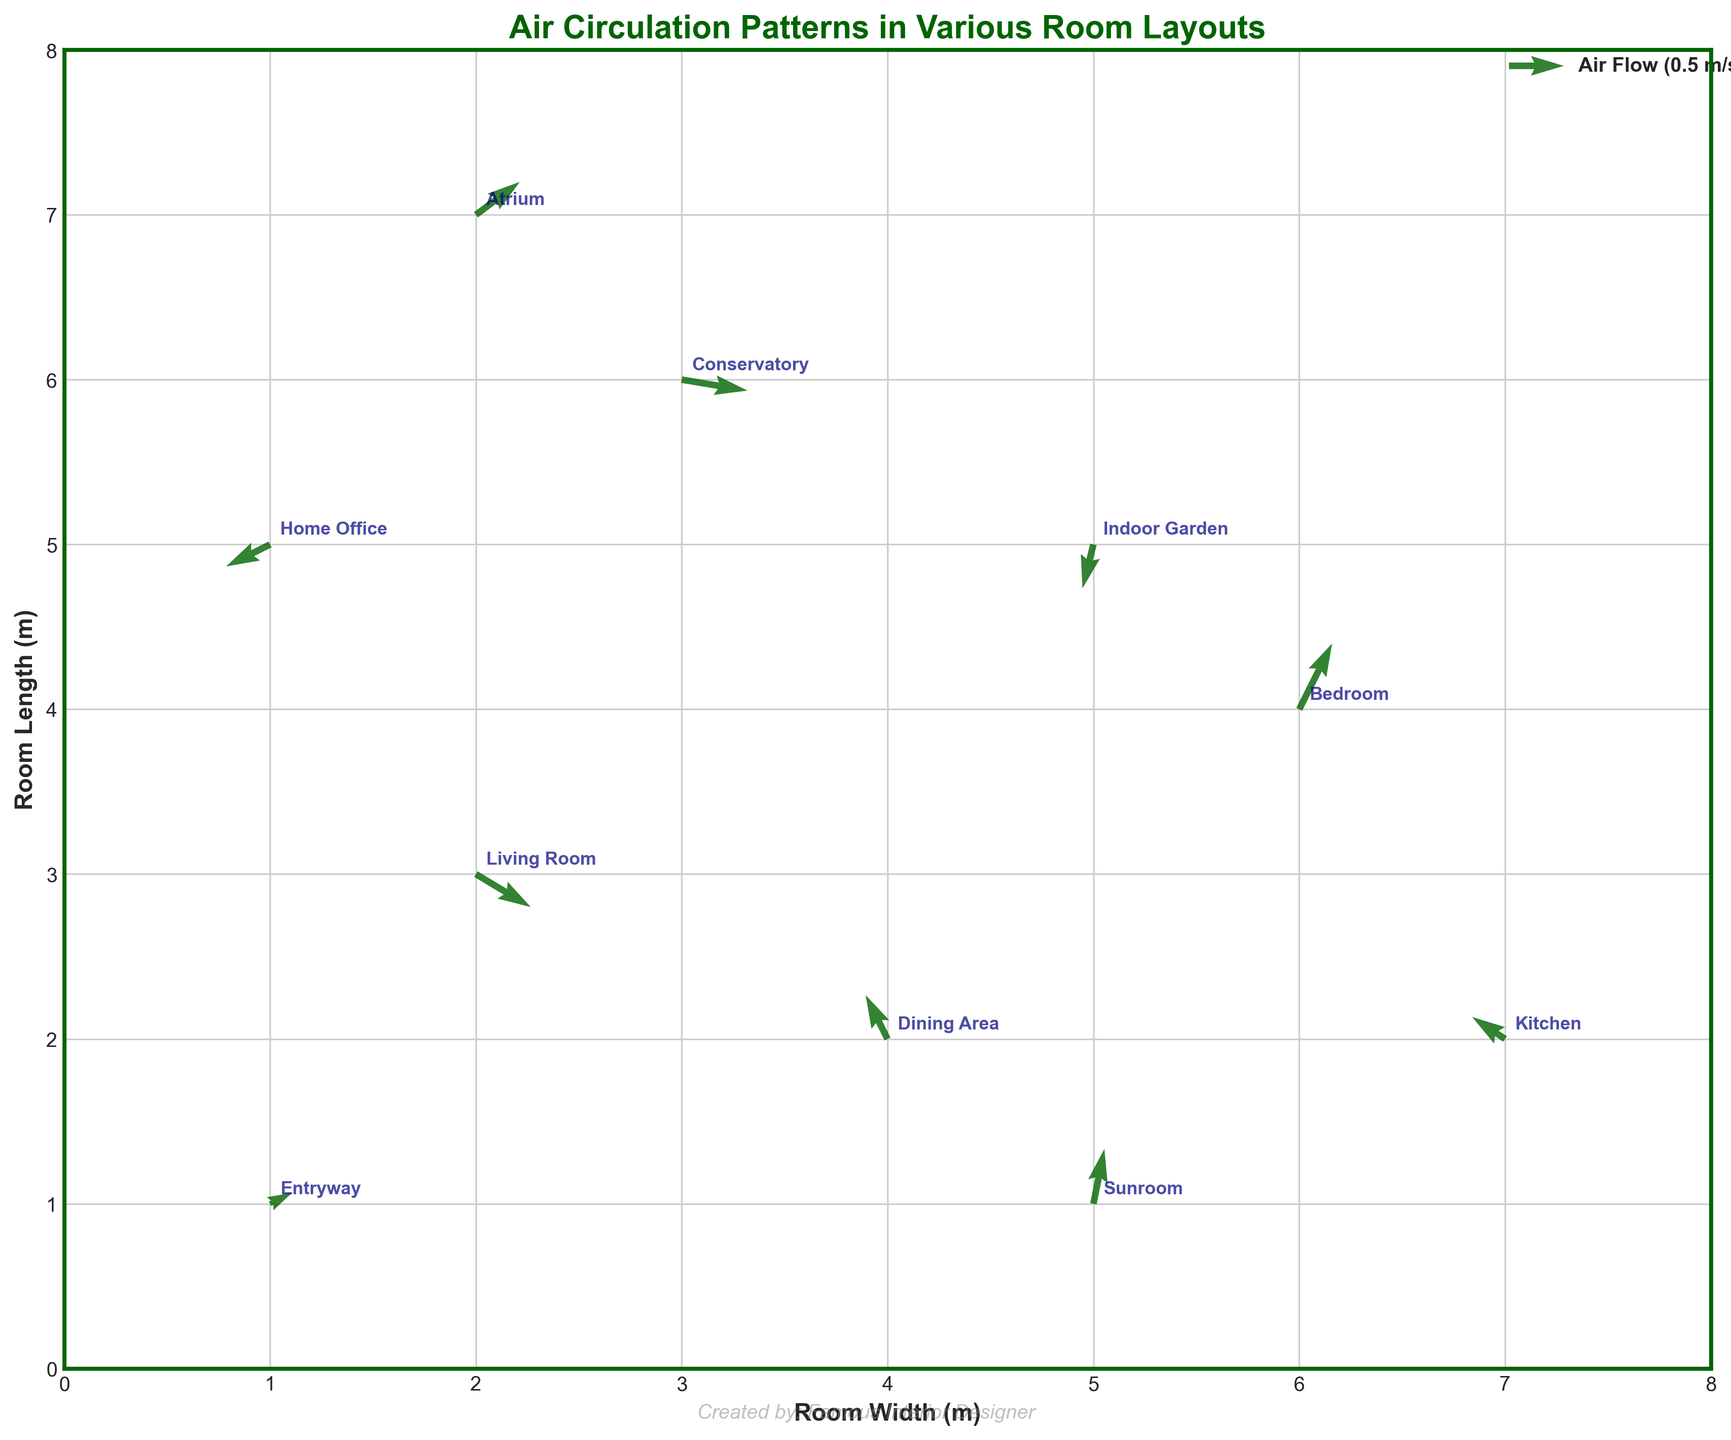What is the color of the arrows representing air flow on the quiver plot? The arrows in the quiver plot are color-coded to indicate the direction and flow of air in each room. In this plot, the arrows are dark green.
Answer: Dark green What is the title of the quiver plot? The title is positioned at the top of the figure, indicating the main subject or focus of the plot. Here, it reads "Air Circulation Patterns in Various Room Layouts".
Answer: Air Circulation Patterns in Various Room Layouts What are the x and y-axis labels in the plot? The x and y-axis labels provide information about what each axis represents. In this plot, the x-axis is labeled "Room Width (m)" and the y-axis is labeled "Room Length (m)".
Answer: Room Width (m), Room Length (m) Which room has a negative air flow in both x and y directions? By analyzing the direction of the arrows (negative values in both the u and v components), we can see that the Home Office (coordinates: 1, 5) has a negative air flow in both directions.
Answer: Home Office What is the maximum positive air flow in the x direction and which room does it belong to? By examining the vectors on the plot, we can determine that the maximum positive air flow in the x direction is 0.6, which belongs to the Conservatory (coordinates: 3, 6).
Answer: Conservatory In which rooms does the air flow have a downward (negative y) component? We need to check the v values for negative components. The rooms with a downward y component are Living Room (coordinates: 2, 3), Home Office (coordinates: 1, 5), Conservatory (coordinates: 3, 6), and Indoor Garden (coordinates: 5, 5).
Answer: Living Room, Home Office, Conservatory, Indoor Garden Compare the air flow direction in the Kitchen and Entryway. Which one has a more upward (positive y) flow direction? We compare the v values for these two rooms. The Kitchen (coordinates: 7, 2) has a v value of 0.2, while the Entryway (coordinates: 1, 1) has a v value of 0.1. Therefore, the Kitchen has a more upward flow direction.
Answer: Kitchen How does the air flow direction in the Atrium compare to the Bedroom? Which room has a greater positive x component? Comparing the x components of the arrows, the Atrium (coordinates: 2, 7) has a u value of 0.4, while the Bedroom (coordinates: 6, 4) has a u value of 0.3. Hence, the Atrium has a greater positive x component.
Answer: Atrium Which room has the smallest magnitude of air flow? To find the smallest magnitude, we calculate the vector magnitude (\(\sqrt{u^2 + v^2}\)) for each room. The Entryway has \(u = 0.2\) and \(v = 0.1\), giving a magnitude of \(\sqrt{0.2^2 + 0.1^2} \approx 0.22\). This is the smallest among all the rooms.
Answer: Entryway What is the general trend of air flow direction in the Sunroom? The Sunroom (coordinates: 5, 1) has an air flow with \(u = 0.1\) (positive x direction) and \(v = 0.5\) (positive y direction). The general trend is an upward-right direction.
Answer: Upward-right direction 